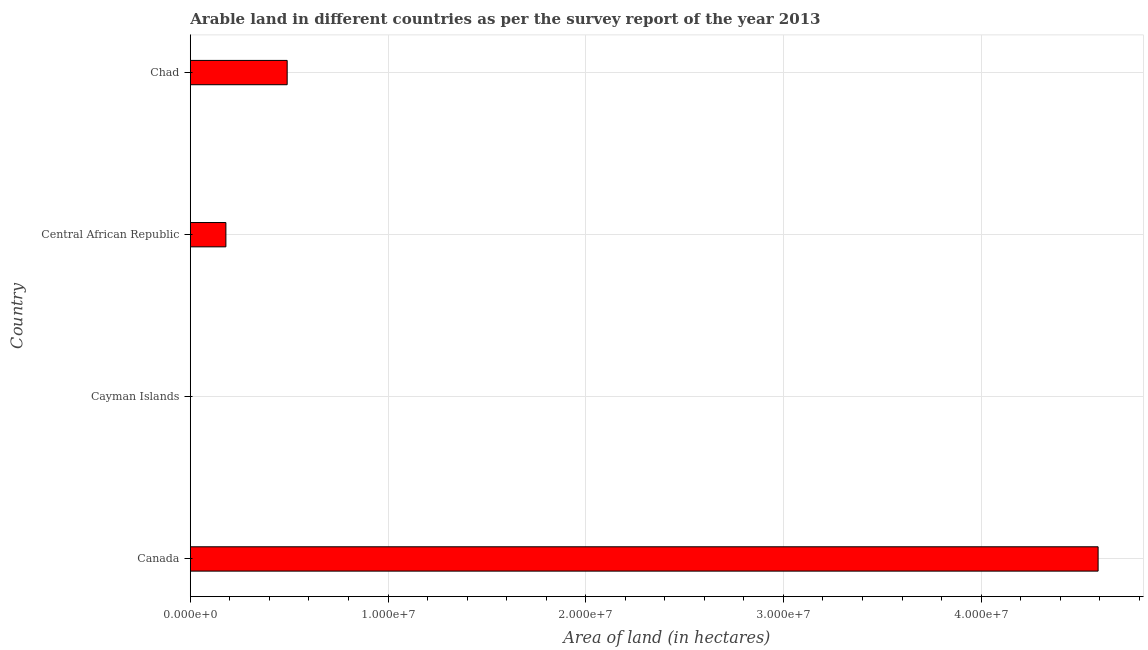What is the title of the graph?
Offer a terse response. Arable land in different countries as per the survey report of the year 2013. What is the label or title of the X-axis?
Your answer should be compact. Area of land (in hectares). What is the area of land in Canada?
Ensure brevity in your answer.  4.59e+07. Across all countries, what is the maximum area of land?
Ensure brevity in your answer.  4.59e+07. Across all countries, what is the minimum area of land?
Provide a short and direct response. 200. In which country was the area of land maximum?
Offer a terse response. Canada. In which country was the area of land minimum?
Provide a short and direct response. Cayman Islands. What is the sum of the area of land?
Provide a succinct answer. 5.26e+07. What is the difference between the area of land in Central African Republic and Chad?
Your response must be concise. -3.10e+06. What is the average area of land per country?
Provide a short and direct response. 1.32e+07. What is the median area of land?
Keep it short and to the point. 3.35e+06. What is the ratio of the area of land in Canada to that in Central African Republic?
Make the answer very short. 25.51. What is the difference between the highest and the second highest area of land?
Your answer should be compact. 4.10e+07. What is the difference between the highest and the lowest area of land?
Your answer should be very brief. 4.59e+07. In how many countries, is the area of land greater than the average area of land taken over all countries?
Your answer should be very brief. 1. Are all the bars in the graph horizontal?
Provide a short and direct response. Yes. How many countries are there in the graph?
Provide a succinct answer. 4. What is the difference between two consecutive major ticks on the X-axis?
Provide a short and direct response. 1.00e+07. Are the values on the major ticks of X-axis written in scientific E-notation?
Keep it short and to the point. Yes. What is the Area of land (in hectares) in Canada?
Give a very brief answer. 4.59e+07. What is the Area of land (in hectares) in Cayman Islands?
Ensure brevity in your answer.  200. What is the Area of land (in hectares) of Central African Republic?
Provide a succinct answer. 1.80e+06. What is the Area of land (in hectares) of Chad?
Offer a very short reply. 4.90e+06. What is the difference between the Area of land (in hectares) in Canada and Cayman Islands?
Your answer should be very brief. 4.59e+07. What is the difference between the Area of land (in hectares) in Canada and Central African Republic?
Ensure brevity in your answer.  4.41e+07. What is the difference between the Area of land (in hectares) in Canada and Chad?
Your answer should be very brief. 4.10e+07. What is the difference between the Area of land (in hectares) in Cayman Islands and Central African Republic?
Make the answer very short. -1.80e+06. What is the difference between the Area of land (in hectares) in Cayman Islands and Chad?
Make the answer very short. -4.90e+06. What is the difference between the Area of land (in hectares) in Central African Republic and Chad?
Give a very brief answer. -3.10e+06. What is the ratio of the Area of land (in hectares) in Canada to that in Cayman Islands?
Your answer should be very brief. 2.30e+05. What is the ratio of the Area of land (in hectares) in Canada to that in Central African Republic?
Provide a succinct answer. 25.51. What is the ratio of the Area of land (in hectares) in Canada to that in Chad?
Provide a short and direct response. 9.37. What is the ratio of the Area of land (in hectares) in Cayman Islands to that in Central African Republic?
Ensure brevity in your answer.  0. What is the ratio of the Area of land (in hectares) in Cayman Islands to that in Chad?
Ensure brevity in your answer.  0. What is the ratio of the Area of land (in hectares) in Central African Republic to that in Chad?
Offer a terse response. 0.37. 